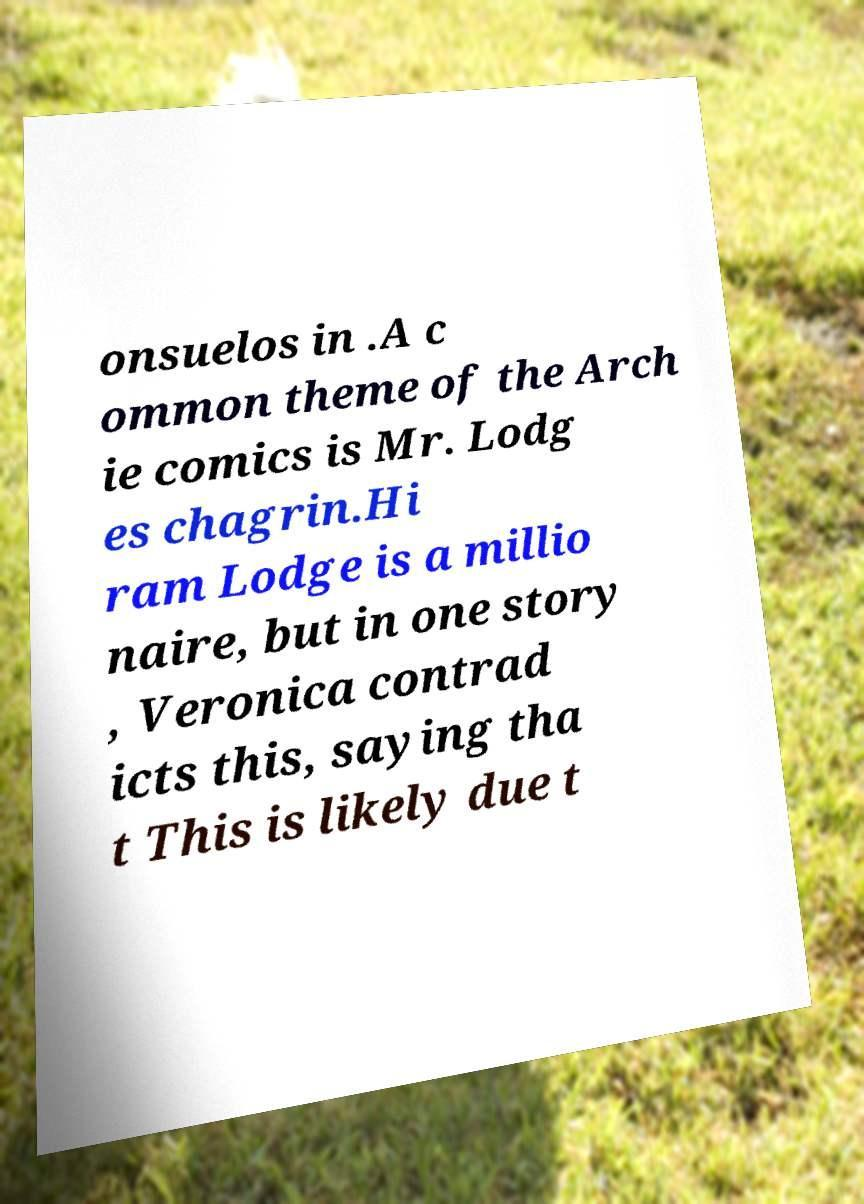Could you assist in decoding the text presented in this image and type it out clearly? onsuelos in .A c ommon theme of the Arch ie comics is Mr. Lodg es chagrin.Hi ram Lodge is a millio naire, but in one story , Veronica contrad icts this, saying tha t This is likely due t 